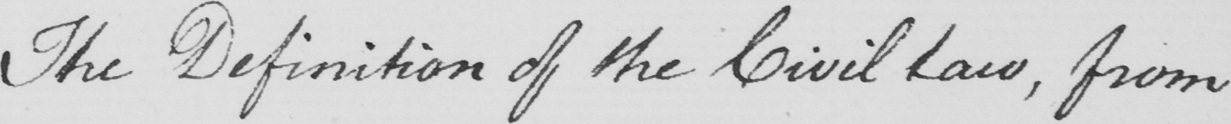Can you tell me what this handwritten text says? The Definition of the Civil Law , from 